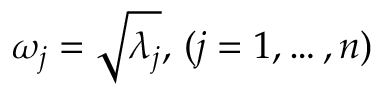<formula> <loc_0><loc_0><loc_500><loc_500>\omega _ { j } = \sqrt { \lambda _ { j } } , \, ( j = 1 , \dots , n )</formula> 